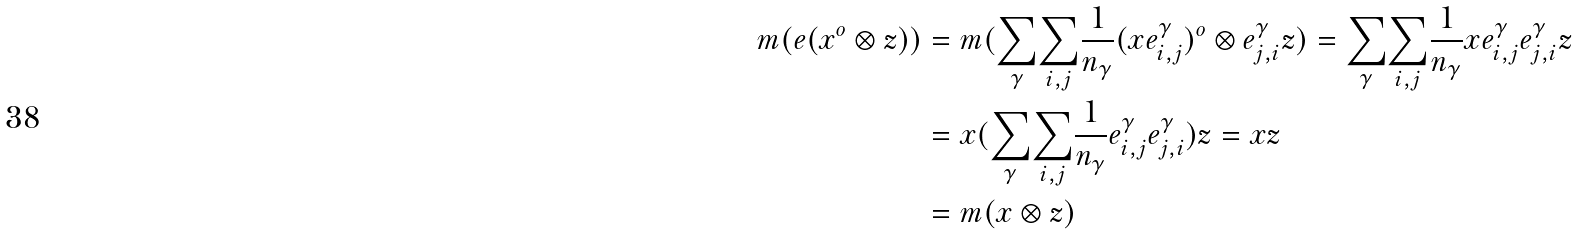<formula> <loc_0><loc_0><loc_500><loc_500>m ( e ( x ^ { o } \otimes z ) ) & = m ( \underset { \gamma } { \sum } \underset { i , j } \sum \frac { 1 } { n _ { \gamma } } { ( x e ^ { \gamma } _ { i , j } } ) ^ { o } \otimes e ^ { \gamma } _ { j , i } z ) = \underset { \gamma } { \sum } \underset { i , j } \sum \frac { 1 } { n _ { \gamma } } x e ^ { \gamma } _ { i , j } e ^ { \gamma } _ { j , i } z \\ & = x ( \underset { \gamma } { \sum } \underset { i , j } \sum \frac { 1 } { n _ { \gamma } } e ^ { \gamma } _ { i , j } e ^ { \gamma } _ { j , i } ) z = x z \\ & = m ( x \otimes z )</formula> 